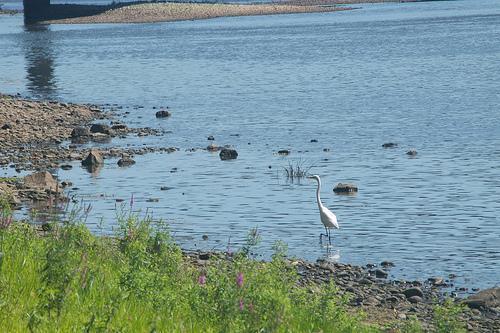How many birds are in the picture?
Give a very brief answer. 1. 